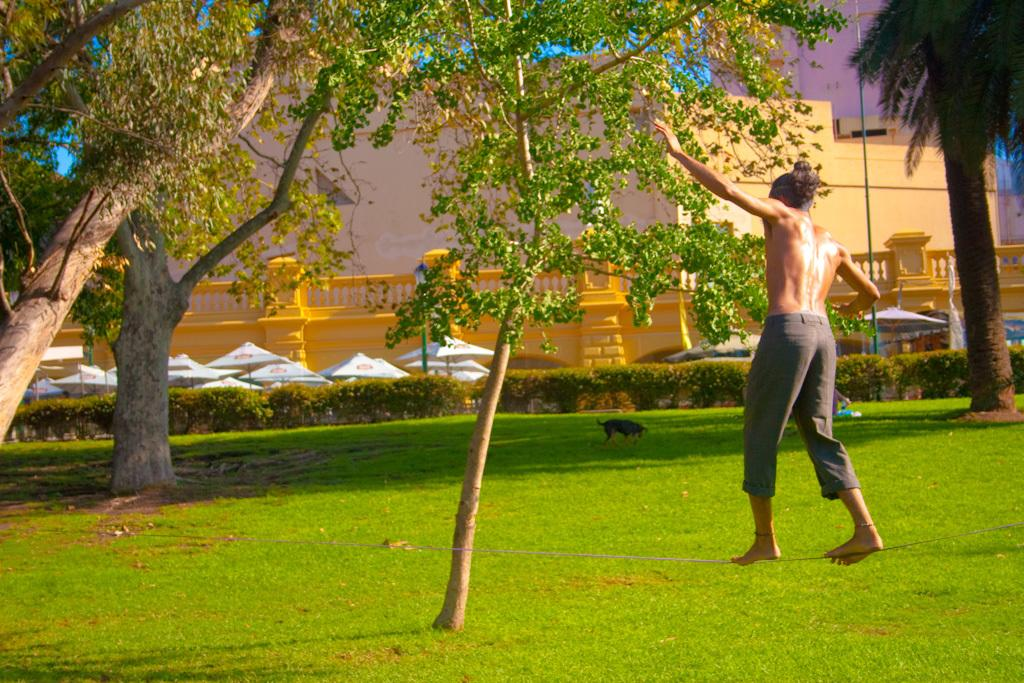What is the person in the image doing? The person is standing on a balancing rope. What can be seen in the background of the image? There are buildings, parasols, trees, the sky, bushes, and an animal in the background of the image. What type of food is being served in the office in the image? There is no office or food present in the image. 